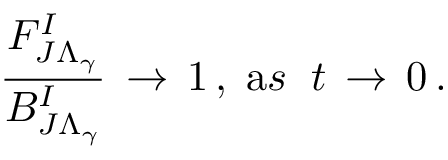Convert formula to latex. <formula><loc_0><loc_0><loc_500><loc_500>\frac { F _ { J \Lambda _ { \gamma } } ^ { I } } { B _ { J \Lambda _ { \gamma } } ^ { I } } \, \rightarrow \, 1 \, , \, { \mathrm a s } \, t \, \rightarrow \, 0 \, .</formula> 